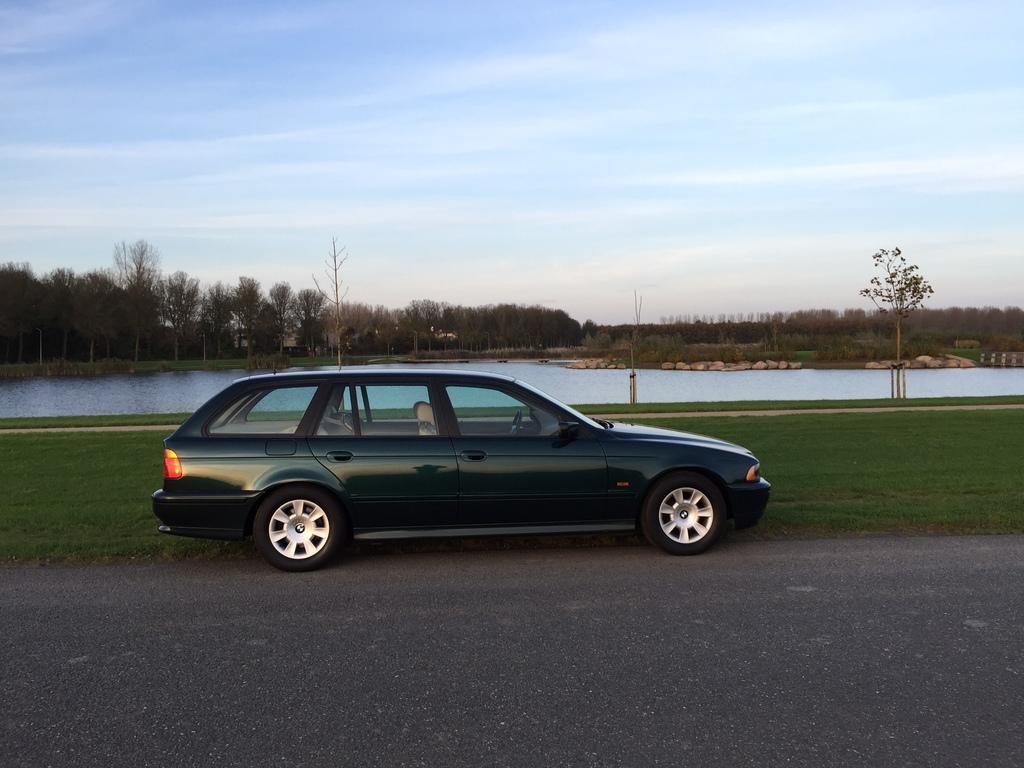Please provide a concise description of this image. This picture is clicked outside on the road. In the center there is a car parked on the ground. In the background we can see the green grass, a water body, trees, rocks and the sky. 